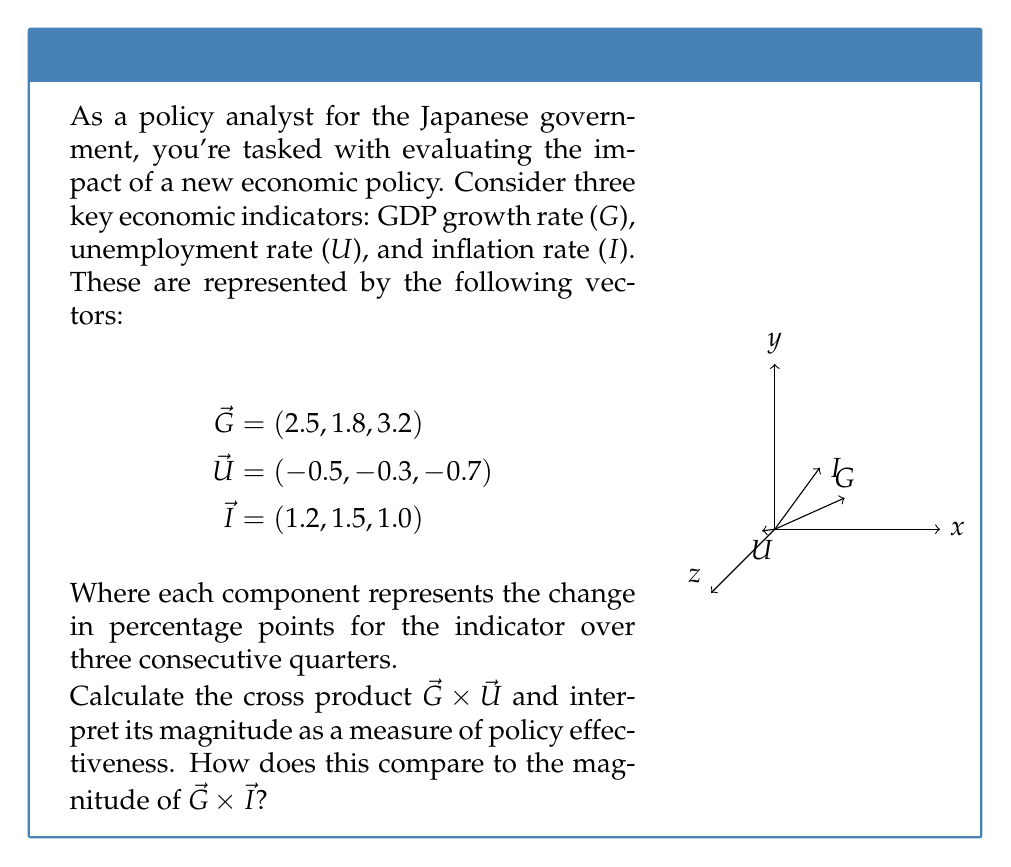Provide a solution to this math problem. Let's approach this step-by-step:

1) First, we need to calculate $\vec{G} \times \vec{U}$. The cross product of two vectors $\vec{a} = (a_1, a_2, a_3)$ and $\vec{b} = (b_1, b_2, b_3)$ is given by:

   $$\vec{a} \times \vec{b} = (a_2b_3 - a_3b_2, a_3b_1 - a_1b_3, a_1b_2 - a_2b_1)$$

2) For $\vec{G} \times \vec{U}$:
   $$(1.8 \cdot (-0.7) - 3.2 \cdot (-0.3), 3.2 \cdot (-0.5) - 2.5 \cdot (-0.7), 2.5 \cdot (-0.3) - 1.8 \cdot (-0.5))$$
   $$= (-1.26 - (-0.96), -1.6 - (-1.75), -0.75 - (-0.9))$$
   $$= (-0.30, 0.15, 0.15)$$

3) The magnitude of this vector is:
   $$\|\vec{G} \times \vec{U}\| = \sqrt{(-0.30)^2 + (0.15)^2 + (0.15)^2} \approx 0.3674$$

4) Now, let's calculate $\vec{G} \times \vec{I}$:
   $$(1.8 \cdot 1.0 - 3.2 \cdot 1.5, 3.2 \cdot 1.2 - 2.5 \cdot 1.0, 2.5 \cdot 1.5 - 1.8 \cdot 1.2)$$
   $$= (1.8 - 4.8, 3.84 - 2.5, 3.75 - 2.16)$$
   $$= (-3.0, 1.34, 1.59)$$

5) The magnitude of this vector is:
   $$\|\vec{G} \times \vec{I}\| = \sqrt{(-3.0)^2 + (1.34)^2 + (1.59)^2} \approx 3.6877$$

6) Interpretation: The magnitude of the cross product represents the area of the parallelogram formed by the two vectors. A larger magnitude indicates a stronger combined effect or interaction between the two factors.

7) In this case, $\|\vec{G} \times \vec{I}\|$ is about 10 times larger than $\|\vec{G} \times \vec{U}\|$, suggesting that the interaction between GDP growth and inflation has a much stronger effect on the economy than the interaction between GDP growth and unemployment under the current policy.
Answer: $\|\vec{G} \times \vec{U}\| \approx 0.3674$, $\|\vec{G} \times \vec{I}\| \approx 3.6877$. The GDP-inflation interaction has a stronger economic impact. 